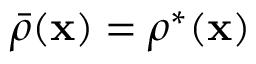Convert formula to latex. <formula><loc_0><loc_0><loc_500><loc_500>\bar { \rho } ( { x } ) = \rho ^ { * } ( { x } )</formula> 